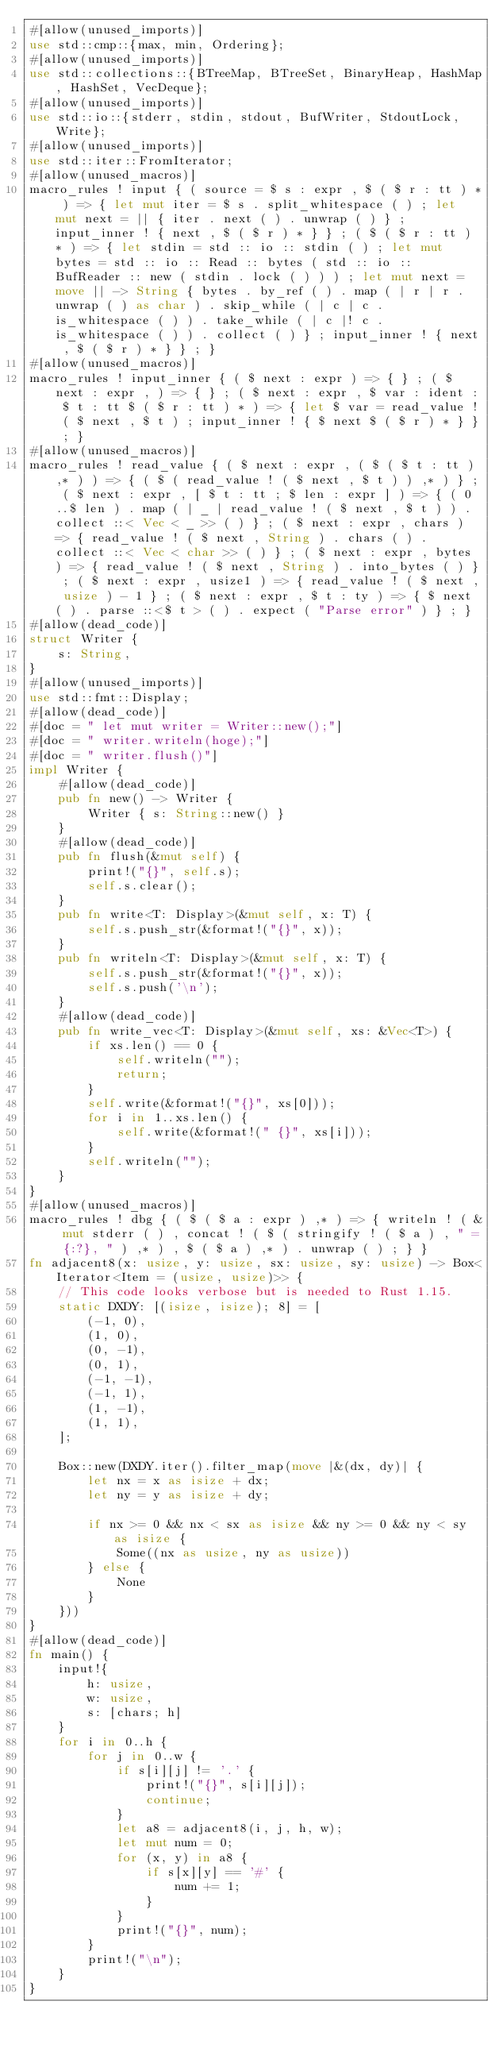<code> <loc_0><loc_0><loc_500><loc_500><_Rust_>#[allow(unused_imports)]
use std::cmp::{max, min, Ordering};
#[allow(unused_imports)]
use std::collections::{BTreeMap, BTreeSet, BinaryHeap, HashMap, HashSet, VecDeque};
#[allow(unused_imports)]
use std::io::{stderr, stdin, stdout, BufWriter, StdoutLock, Write};
#[allow(unused_imports)]
use std::iter::FromIterator;
#[allow(unused_macros)]
macro_rules ! input { ( source = $ s : expr , $ ( $ r : tt ) * ) => { let mut iter = $ s . split_whitespace ( ) ; let mut next = || { iter . next ( ) . unwrap ( ) } ; input_inner ! { next , $ ( $ r ) * } } ; ( $ ( $ r : tt ) * ) => { let stdin = std :: io :: stdin ( ) ; let mut bytes = std :: io :: Read :: bytes ( std :: io :: BufReader :: new ( stdin . lock ( ) ) ) ; let mut next = move || -> String { bytes . by_ref ( ) . map ( | r | r . unwrap ( ) as char ) . skip_while ( | c | c . is_whitespace ( ) ) . take_while ( | c |! c . is_whitespace ( ) ) . collect ( ) } ; input_inner ! { next , $ ( $ r ) * } } ; }
#[allow(unused_macros)]
macro_rules ! input_inner { ( $ next : expr ) => { } ; ( $ next : expr , ) => { } ; ( $ next : expr , $ var : ident : $ t : tt $ ( $ r : tt ) * ) => { let $ var = read_value ! ( $ next , $ t ) ; input_inner ! { $ next $ ( $ r ) * } } ; }
#[allow(unused_macros)]
macro_rules ! read_value { ( $ next : expr , ( $ ( $ t : tt ) ,* ) ) => { ( $ ( read_value ! ( $ next , $ t ) ) ,* ) } ; ( $ next : expr , [ $ t : tt ; $ len : expr ] ) => { ( 0 ..$ len ) . map ( | _ | read_value ! ( $ next , $ t ) ) . collect ::< Vec < _ >> ( ) } ; ( $ next : expr , chars ) => { read_value ! ( $ next , String ) . chars ( ) . collect ::< Vec < char >> ( ) } ; ( $ next : expr , bytes ) => { read_value ! ( $ next , String ) . into_bytes ( ) } ; ( $ next : expr , usize1 ) => { read_value ! ( $ next , usize ) - 1 } ; ( $ next : expr , $ t : ty ) => { $ next ( ) . parse ::<$ t > ( ) . expect ( "Parse error" ) } ; }
#[allow(dead_code)]
struct Writer {
    s: String,
}
#[allow(unused_imports)]
use std::fmt::Display;
#[allow(dead_code)]
#[doc = " let mut writer = Writer::new();"]
#[doc = " writer.writeln(hoge);"]
#[doc = " writer.flush()"]
impl Writer {
    #[allow(dead_code)]
    pub fn new() -> Writer {
        Writer { s: String::new() }
    }
    #[allow(dead_code)]
    pub fn flush(&mut self) {
        print!("{}", self.s);
        self.s.clear();
    }
    pub fn write<T: Display>(&mut self, x: T) {
        self.s.push_str(&format!("{}", x));
    }
    pub fn writeln<T: Display>(&mut self, x: T) {
        self.s.push_str(&format!("{}", x));
        self.s.push('\n');
    }
    #[allow(dead_code)]
    pub fn write_vec<T: Display>(&mut self, xs: &Vec<T>) {
        if xs.len() == 0 {
            self.writeln("");
            return;
        }
        self.write(&format!("{}", xs[0]));
        for i in 1..xs.len() {
            self.write(&format!(" {}", xs[i]));
        }
        self.writeln("");
    }
}
#[allow(unused_macros)]
macro_rules ! dbg { ( $ ( $ a : expr ) ,* ) => { writeln ! ( & mut stderr ( ) , concat ! ( $ ( stringify ! ( $ a ) , " = {:?}, " ) ,* ) , $ ( $ a ) ,* ) . unwrap ( ) ; } }
fn adjacent8(x: usize, y: usize, sx: usize, sy: usize) -> Box<Iterator<Item = (usize, usize)>> {
    // This code looks verbose but is needed to Rust 1.15.
    static DXDY: [(isize, isize); 8] = [
        (-1, 0),
        (1, 0),
        (0, -1),
        (0, 1),
        (-1, -1),
        (-1, 1),
        (1, -1),
        (1, 1),
    ];

    Box::new(DXDY.iter().filter_map(move |&(dx, dy)| {
        let nx = x as isize + dx;
        let ny = y as isize + dy;

        if nx >= 0 && nx < sx as isize && ny >= 0 && ny < sy as isize {
            Some((nx as usize, ny as usize))
        } else {
            None
        }
    }))
}
#[allow(dead_code)]
fn main() {
    input!{
        h: usize,
        w: usize,
        s: [chars; h]
    }
    for i in 0..h {
        for j in 0..w {
            if s[i][j] != '.' {
                print!("{}", s[i][j]);
                continue;
            }
            let a8 = adjacent8(i, j, h, w);
            let mut num = 0;
            for (x, y) in a8 {
                if s[x][y] == '#' {
                    num += 1;
                }
            }
            print!("{}", num);
        }
        print!("\n");
    }
}</code> 